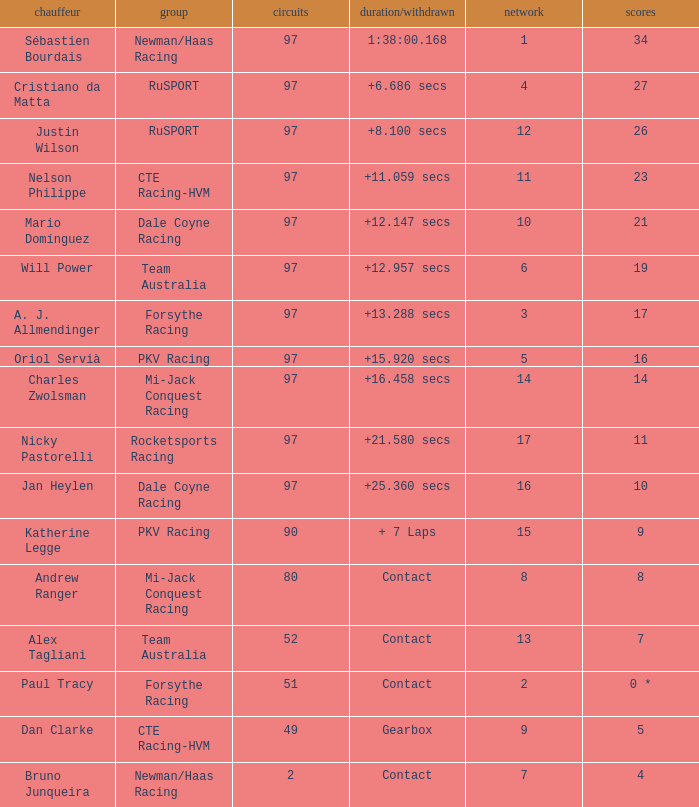What is the highest number of laps for the driver with 5 points? 49.0. 